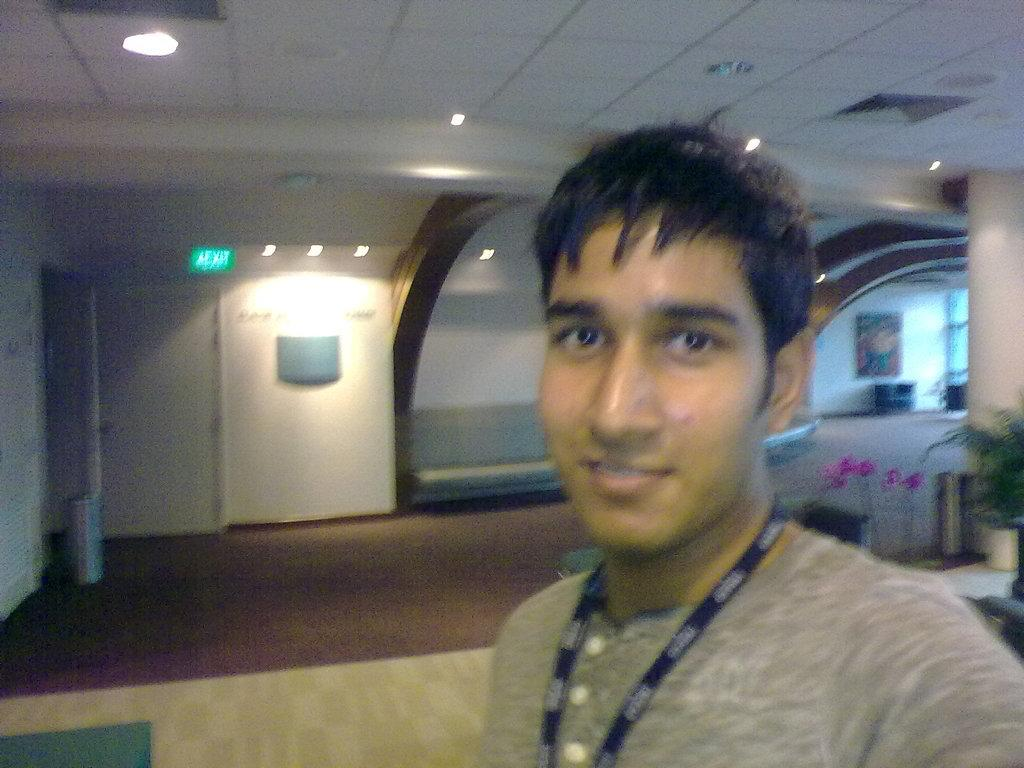What is present in the image? There is a person, flowerpots, a door, lights, a ceiling, a wall, and a floor in the image. Can you describe the person in the image? The provided facts do not give any information about the person's appearance or clothing. What type of lights are visible in the image? The facts do not specify the type of lights in the image. What is the color of the wall in the image? The provided facts do not mention the color of the wall. How many kittens are playing on the patch in the image? There are no kittens or patches present in the image. What type of music is the band playing in the image? There is no band present in the image. 